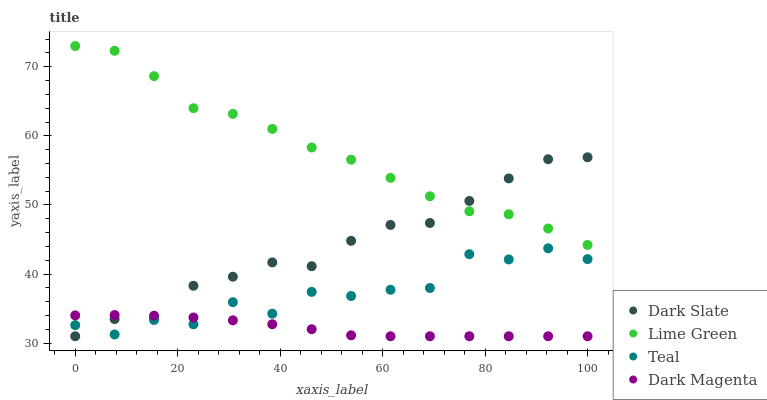Does Dark Magenta have the minimum area under the curve?
Answer yes or no. Yes. Does Lime Green have the maximum area under the curve?
Answer yes or no. Yes. Does Lime Green have the minimum area under the curve?
Answer yes or no. No. Does Dark Magenta have the maximum area under the curve?
Answer yes or no. No. Is Dark Magenta the smoothest?
Answer yes or no. Yes. Is Teal the roughest?
Answer yes or no. Yes. Is Lime Green the smoothest?
Answer yes or no. No. Is Lime Green the roughest?
Answer yes or no. No. Does Dark Slate have the lowest value?
Answer yes or no. Yes. Does Lime Green have the lowest value?
Answer yes or no. No. Does Lime Green have the highest value?
Answer yes or no. Yes. Does Dark Magenta have the highest value?
Answer yes or no. No. Is Teal less than Lime Green?
Answer yes or no. Yes. Is Lime Green greater than Teal?
Answer yes or no. Yes. Does Dark Slate intersect Teal?
Answer yes or no. Yes. Is Dark Slate less than Teal?
Answer yes or no. No. Is Dark Slate greater than Teal?
Answer yes or no. No. Does Teal intersect Lime Green?
Answer yes or no. No. 